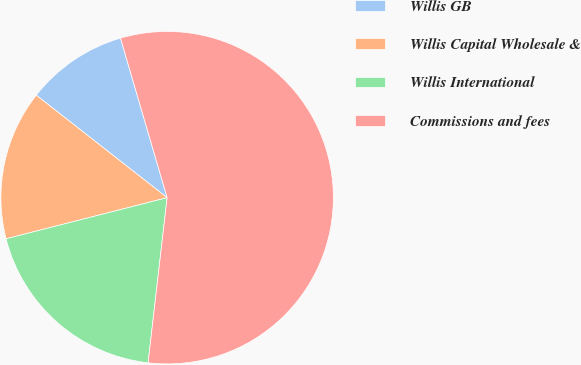Convert chart to OTSL. <chart><loc_0><loc_0><loc_500><loc_500><pie_chart><fcel>Willis GB<fcel>Willis Capital Wholesale &<fcel>Willis International<fcel>Commissions and fees<nl><fcel>9.9%<fcel>14.55%<fcel>19.19%<fcel>56.35%<nl></chart> 